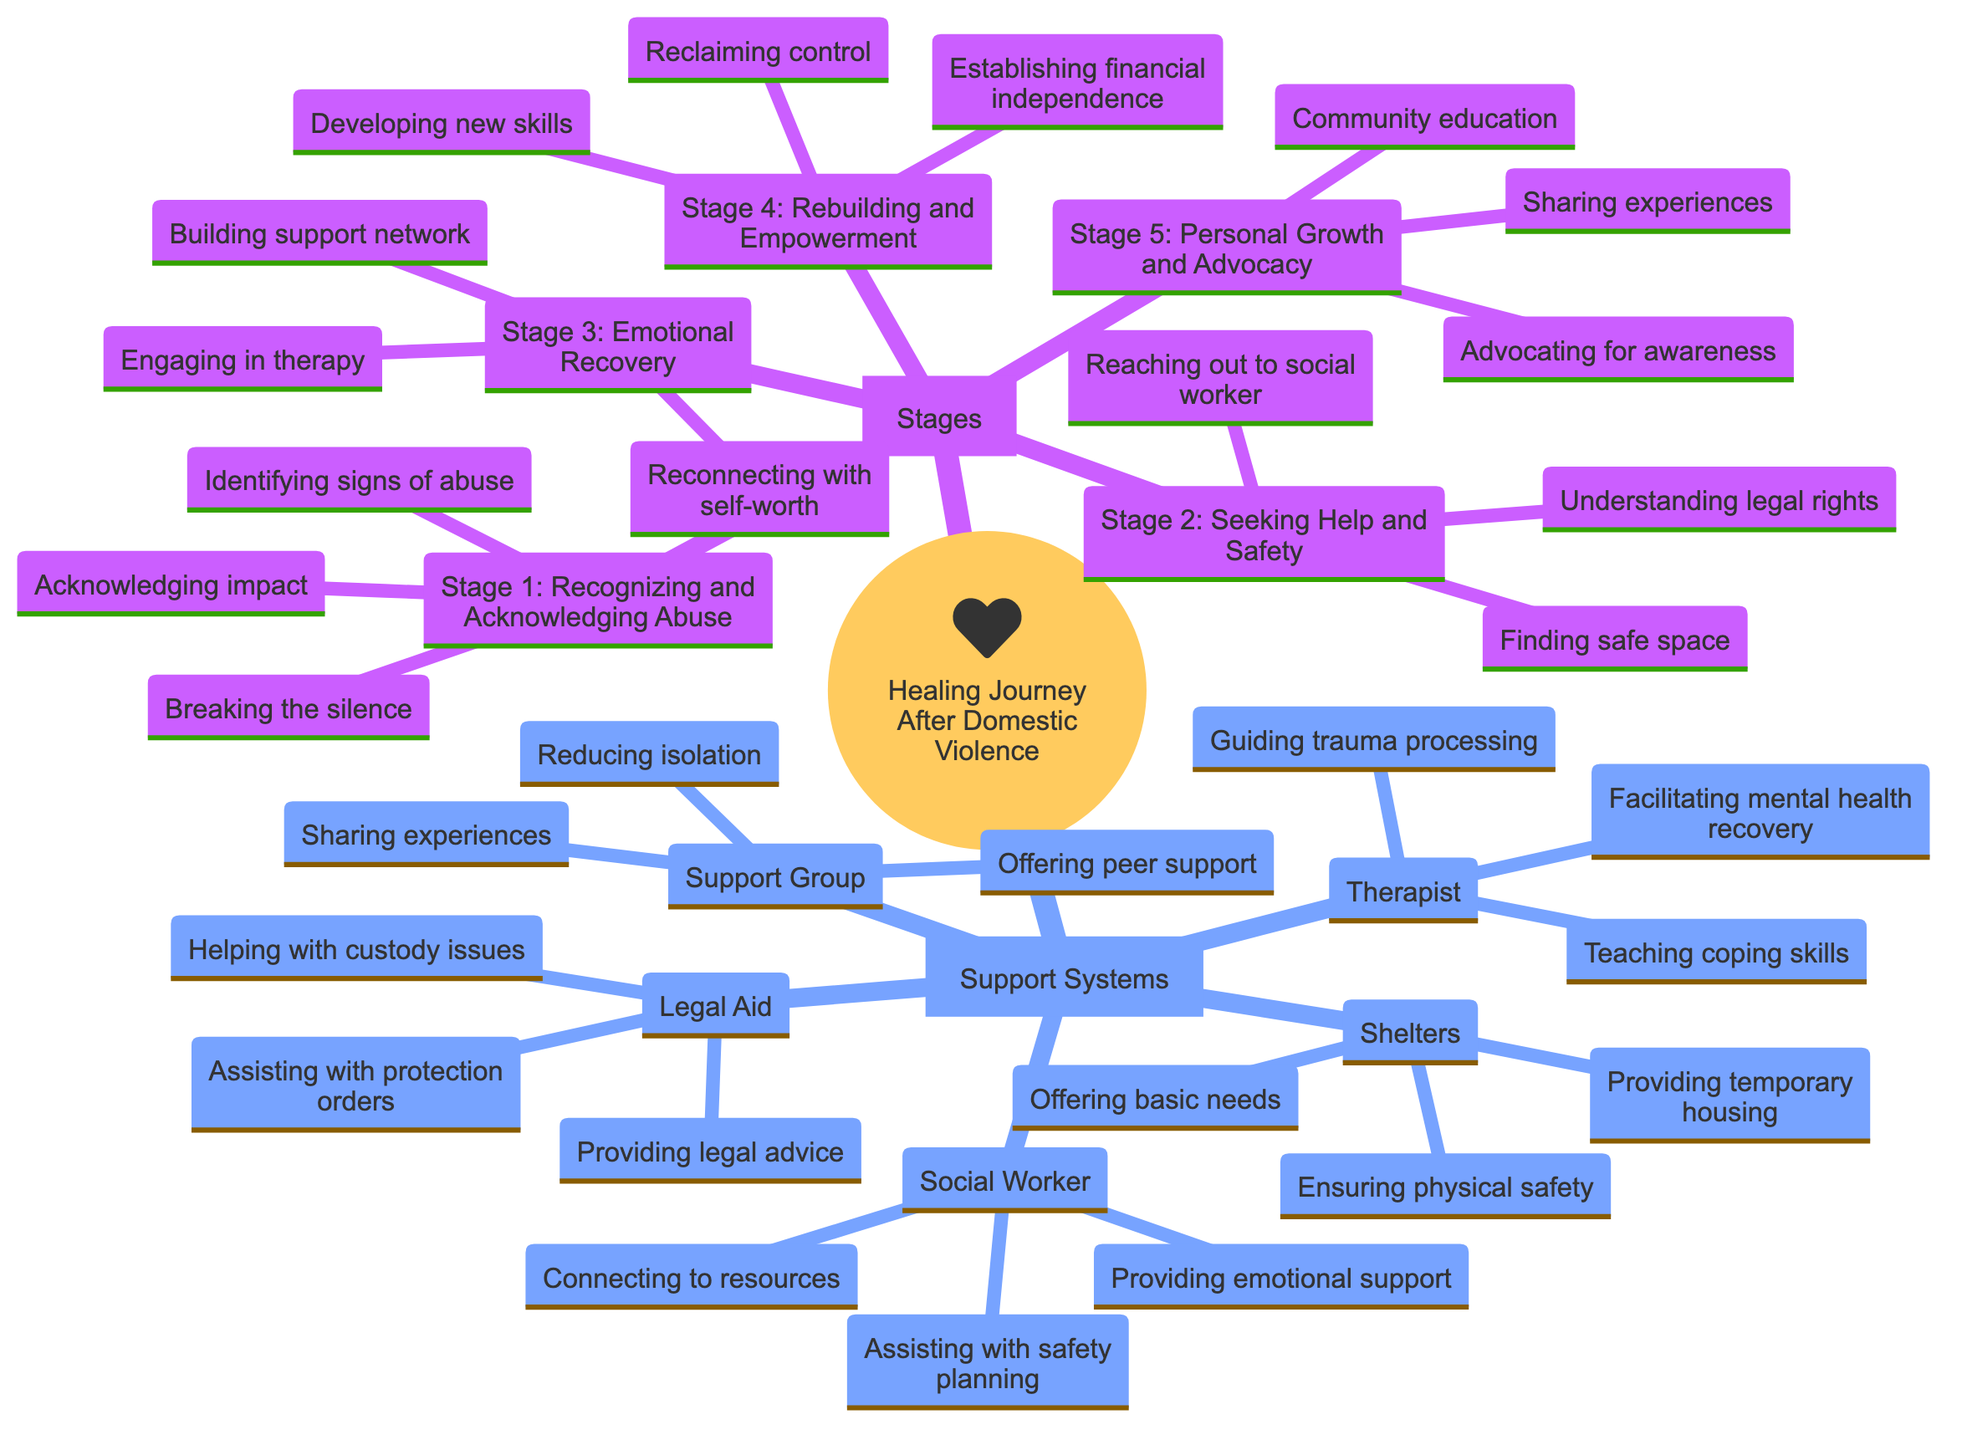What are the five stages of healing after domestic violence? The diagram lists five stages: Recognizing and Acknowledging Abuse, Seeking Help and Safety, Emotional Recovery, Rebuilding and Empowerment, and Personal Growth and Advocacy.
Answer: Recognizing and Acknowledging Abuse, Seeking Help and Safety, Emotional Recovery, Rebuilding and Empowerment, Personal Growth and Advocacy How many milestones are in Stage 2? In Stage 2: Seeking Help and Safety, there are three milestones: Reaching out to a social worker, Finding a safe space, and Understanding legal rights and options.
Answer: 3 What support role assists with safety planning? The support role that assists with safety planning is the Social Worker. This can be identified under the Support Systems section where the roles of Social Worker are listed.
Answer: Social Worker Which stage focuses on rebuilding after experiencing domestic violence? Stage 4 is focused on Rebuilding and Empowerment, which involves developing new skills and interests and establishing financial independence.
Answer: Rebuilding and Empowerment What is one milestone of the Emotional Recovery stage? One milestone of the Emotional Recovery stage is Engaging in therapy, which is listed under Stage 3 in the diagram.
Answer: Engaging in therapy How many roles does the therapist fulfill? The Therapist has three roles: Facilitating mental health recovery, Teaching coping skills, and Guiding through trauma processing, which can be directly counted from the diagram.
Answer: 3 What is a key milestone of the Personal Growth and Advocacy stage? A key milestone of the Personal Growth and Advocacy stage is Sharing experiences to help others, as indicated in Stage 5.
Answer: Sharing experiences to help others What type of support does a Shelter provide? A Shelter provides temporary housing, which is clearly listed under the Support Systems section of the diagram.
Answer: Temporary housing Which support system offers peer support? The Support Group offers peer support, as indicated in its roles under the Support Systems portion of the diagram.
Answer: Support Group 